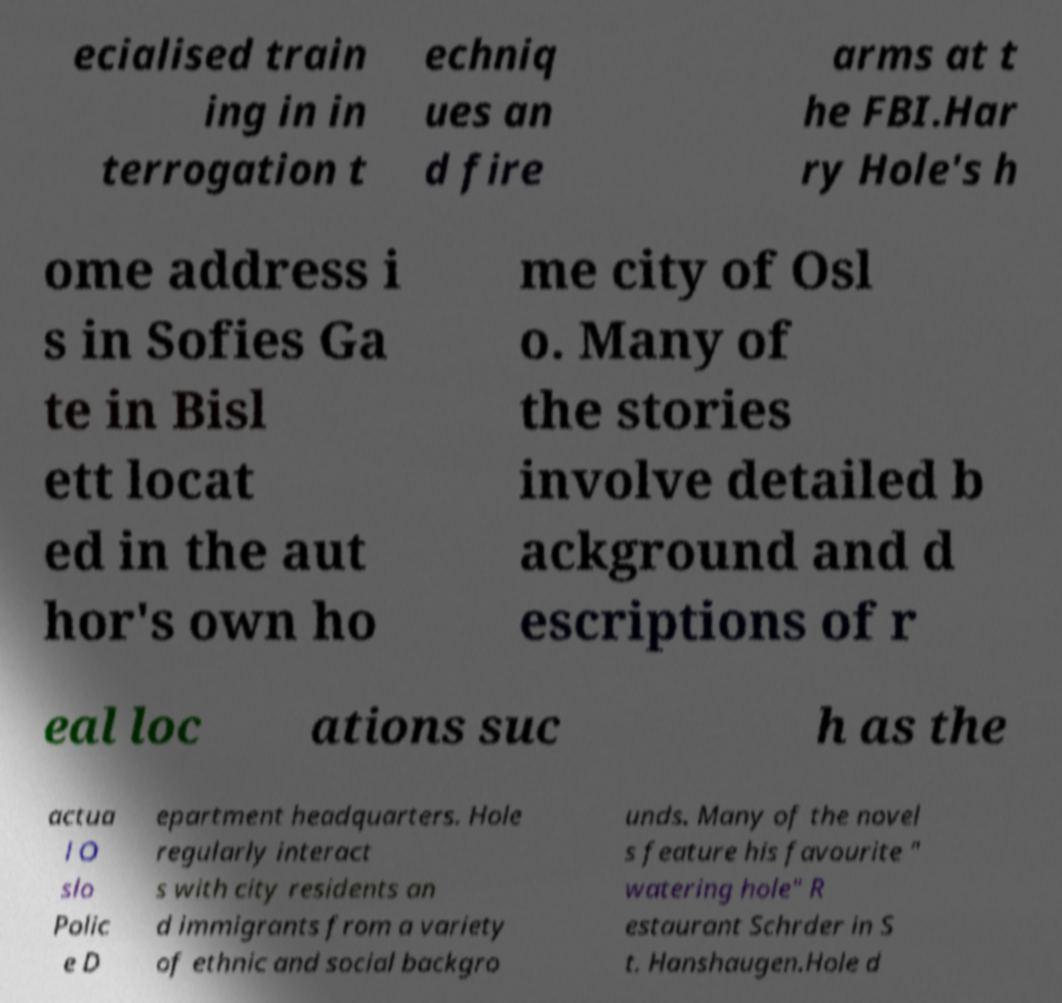I need the written content from this picture converted into text. Can you do that? ecialised train ing in in terrogation t echniq ues an d fire arms at t he FBI.Har ry Hole's h ome address i s in Sofies Ga te in Bisl ett locat ed in the aut hor's own ho me city of Osl o. Many of the stories involve detailed b ackground and d escriptions of r eal loc ations suc h as the actua l O slo Polic e D epartment headquarters. Hole regularly interact s with city residents an d immigrants from a variety of ethnic and social backgro unds. Many of the novel s feature his favourite " watering hole" R estaurant Schrder in S t. Hanshaugen.Hole d 